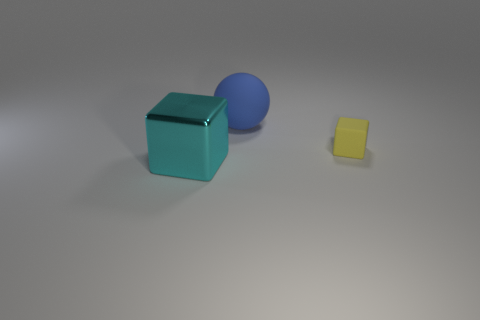Add 2 yellow rubber things. How many objects exist? 5 Subtract all cubes. How many objects are left? 1 Subtract 0 yellow cylinders. How many objects are left? 3 Subtract all tiny yellow shiny balls. Subtract all cyan cubes. How many objects are left? 2 Add 1 tiny yellow blocks. How many tiny yellow blocks are left? 2 Add 2 big things. How many big things exist? 4 